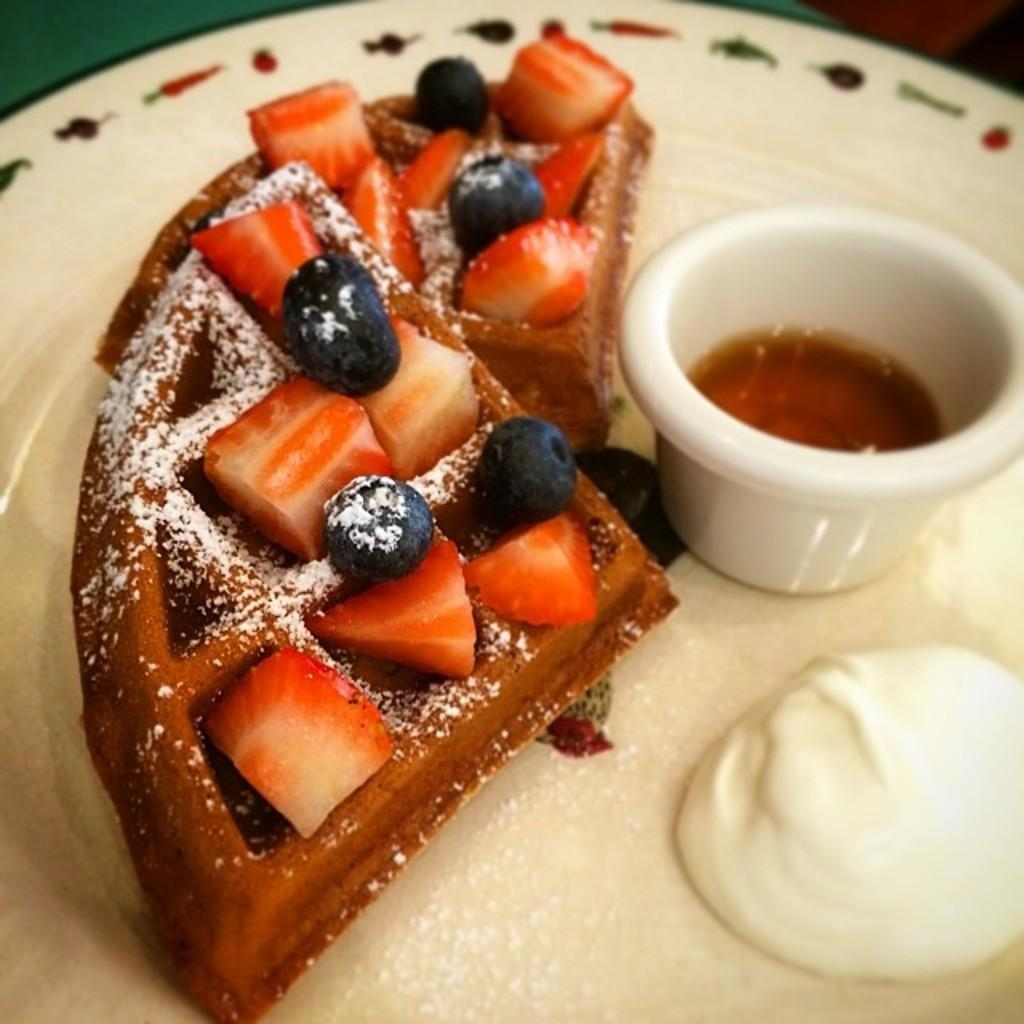What types of food items can be seen in the image? There are food items in the image, but the specific types cannot be determined without more information. Can you describe any specific details about the food items? There is a small cup with some sauce on the plate. What type of science experiment is being conducted in the image? There is no indication of a science experiment in the image; it features food items and a small cup with sauce on the plate. Can you see any chess pieces on the table in the image? There is no mention of chess pieces or a chessboard in the image. 